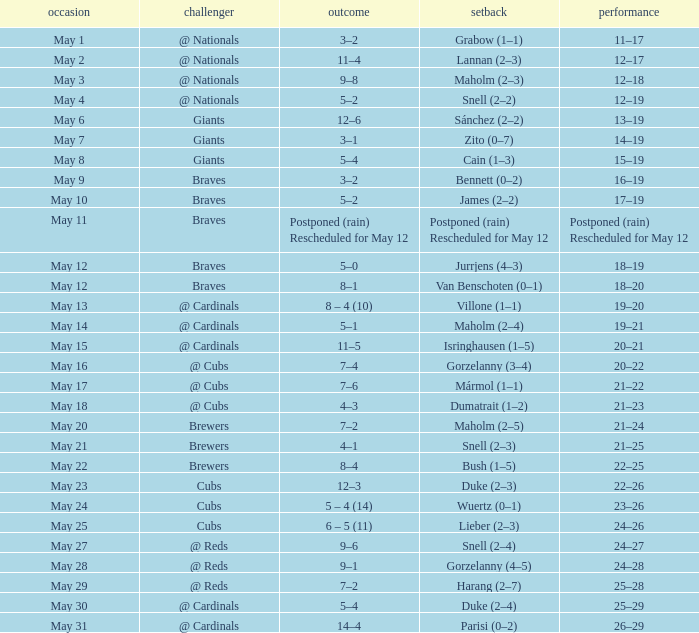What was the score of the game with a loss of Maholm (2–4)? 5–1. 